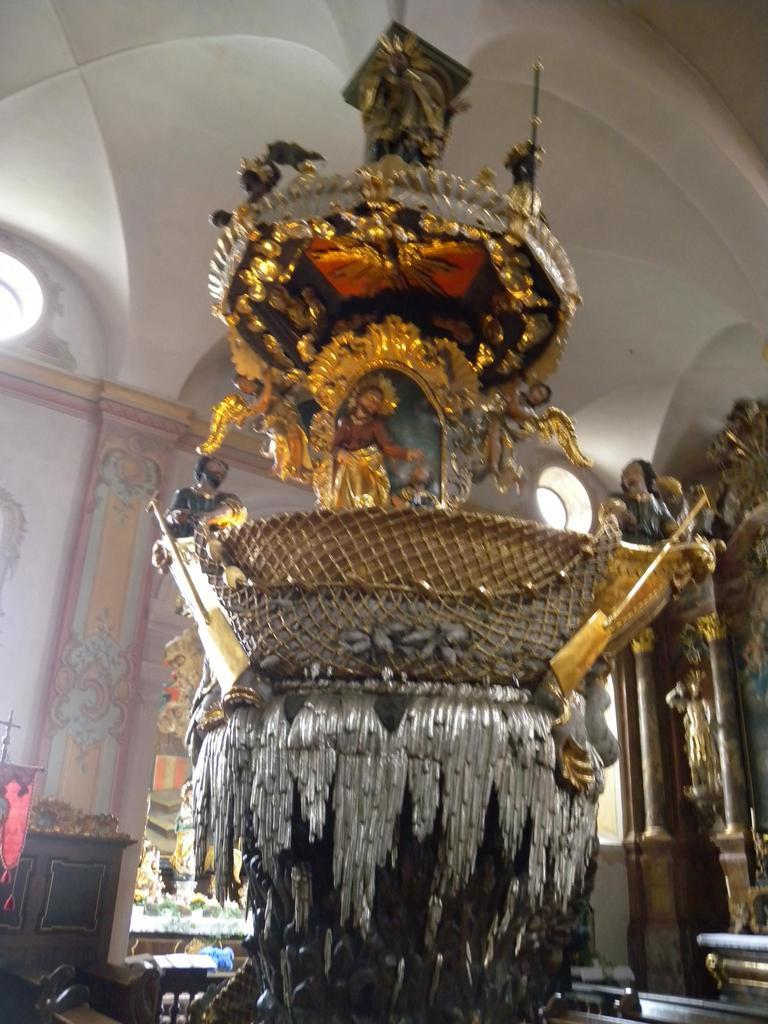What is the main subject in the center of the image? There is a statue in the center of the image. What can be seen in the background of the image? There are objects in the background of the image. What feature is present near the statue? There is a railing visible in the image. What is located at the top of the image? There is a roof at the top of the image. How many cattle are visible in the image? There are no cattle present in the image. What type of stocking is the statue wearing in the image? The statue does not have any stockings, as it is a statue and not a person. 